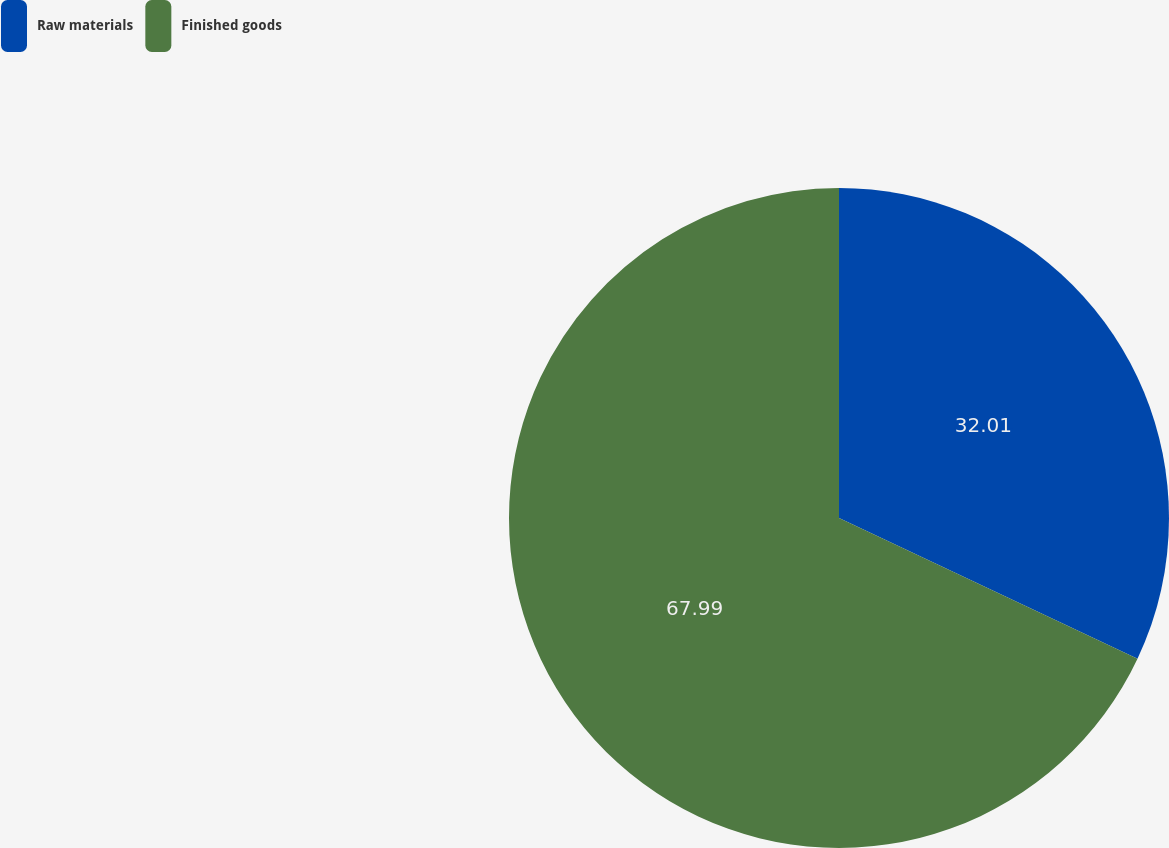<chart> <loc_0><loc_0><loc_500><loc_500><pie_chart><fcel>Raw materials<fcel>Finished goods<nl><fcel>32.01%<fcel>67.99%<nl></chart> 